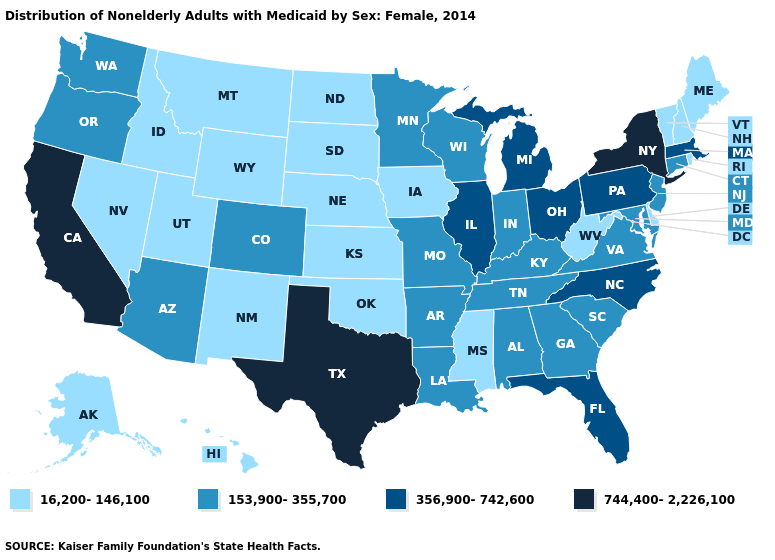Among the states that border Idaho , does Washington have the lowest value?
Concise answer only. No. Which states have the highest value in the USA?
Concise answer only. California, New York, Texas. Among the states that border Indiana , does Illinois have the highest value?
Quick response, please. Yes. Is the legend a continuous bar?
Give a very brief answer. No. Name the states that have a value in the range 356,900-742,600?
Quick response, please. Florida, Illinois, Massachusetts, Michigan, North Carolina, Ohio, Pennsylvania. What is the highest value in states that border Minnesota?
Quick response, please. 153,900-355,700. What is the lowest value in the USA?
Short answer required. 16,200-146,100. Among the states that border Iowa , does Illinois have the highest value?
Concise answer only. Yes. Name the states that have a value in the range 16,200-146,100?
Quick response, please. Alaska, Delaware, Hawaii, Idaho, Iowa, Kansas, Maine, Mississippi, Montana, Nebraska, Nevada, New Hampshire, New Mexico, North Dakota, Oklahoma, Rhode Island, South Dakota, Utah, Vermont, West Virginia, Wyoming. Which states hav the highest value in the South?
Give a very brief answer. Texas. Does the first symbol in the legend represent the smallest category?
Be succinct. Yes. Which states have the lowest value in the USA?
Concise answer only. Alaska, Delaware, Hawaii, Idaho, Iowa, Kansas, Maine, Mississippi, Montana, Nebraska, Nevada, New Hampshire, New Mexico, North Dakota, Oklahoma, Rhode Island, South Dakota, Utah, Vermont, West Virginia, Wyoming. What is the value of Kentucky?
Short answer required. 153,900-355,700. What is the value of New Mexico?
Concise answer only. 16,200-146,100. Which states hav the highest value in the South?
Quick response, please. Texas. 